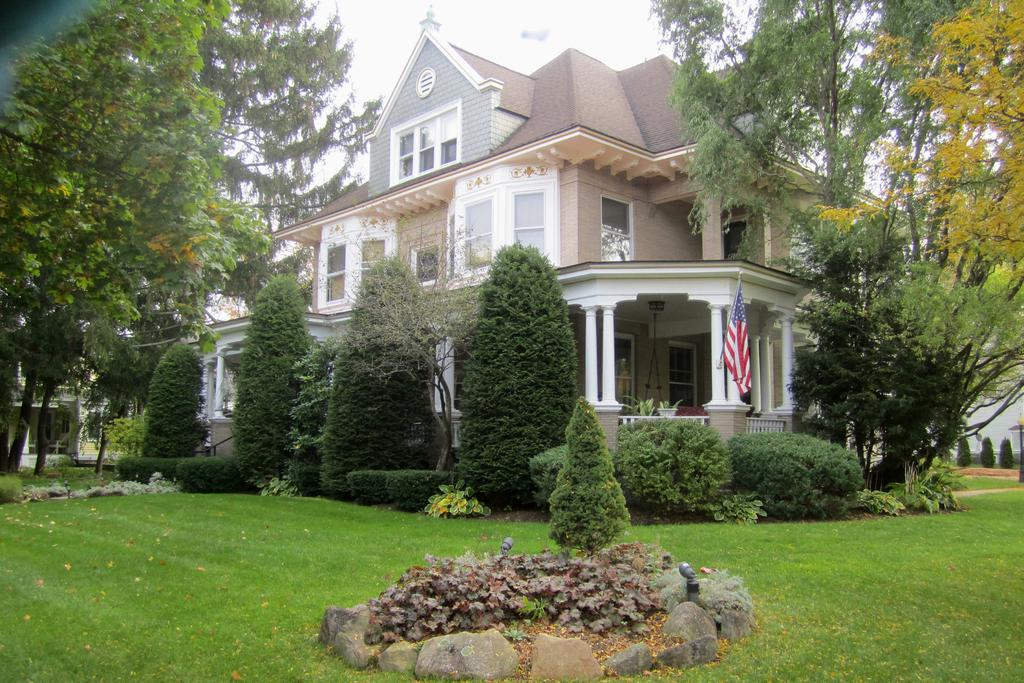What type of structure is present in the image? There is a building in the image. What features can be observed on the building? The building has doors and windows. What natural elements are visible in the image? There are trees, plants, and stones on the ground in the image. The ground is covered with grass. What part of the natural environment is visible in the image? The sky is visible in the image. What arithmetic problem is being solved on the building's facade in the image? There is no arithmetic problem visible on the building's facade in the image. Is the substance of the building made of snow? The building is not made of snow; it is a solid structure. 